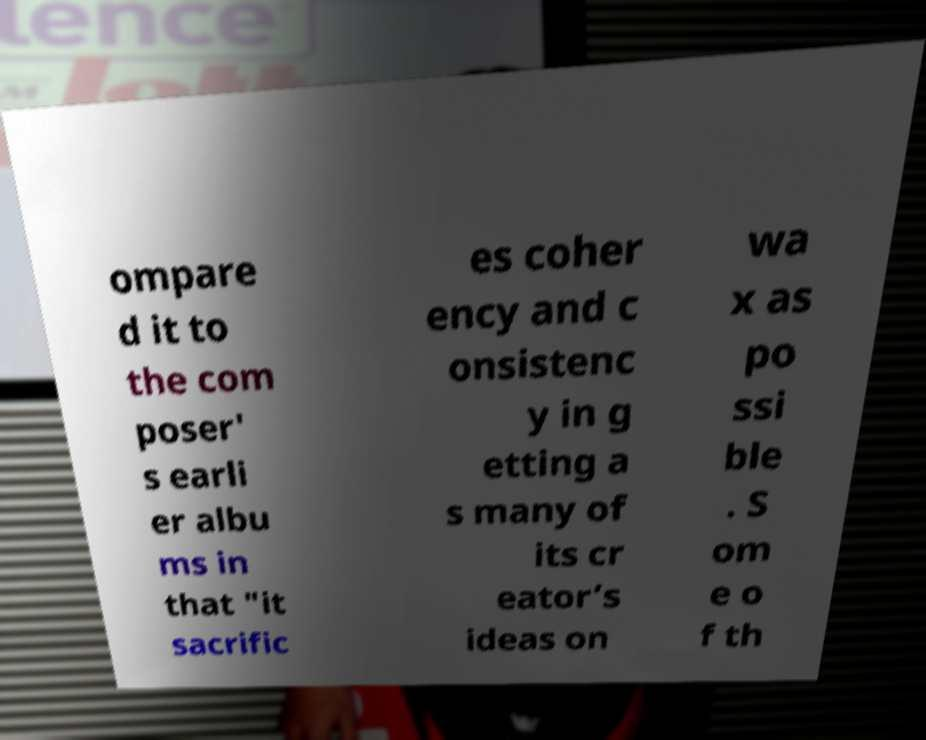Could you extract and type out the text from this image? ompare d it to the com poser' s earli er albu ms in that "it sacrific es coher ency and c onsistenc y in g etting a s many of its cr eator’s ideas on wa x as po ssi ble . S om e o f th 